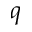<formula> <loc_0><loc_0><loc_500><loc_500>q</formula> 